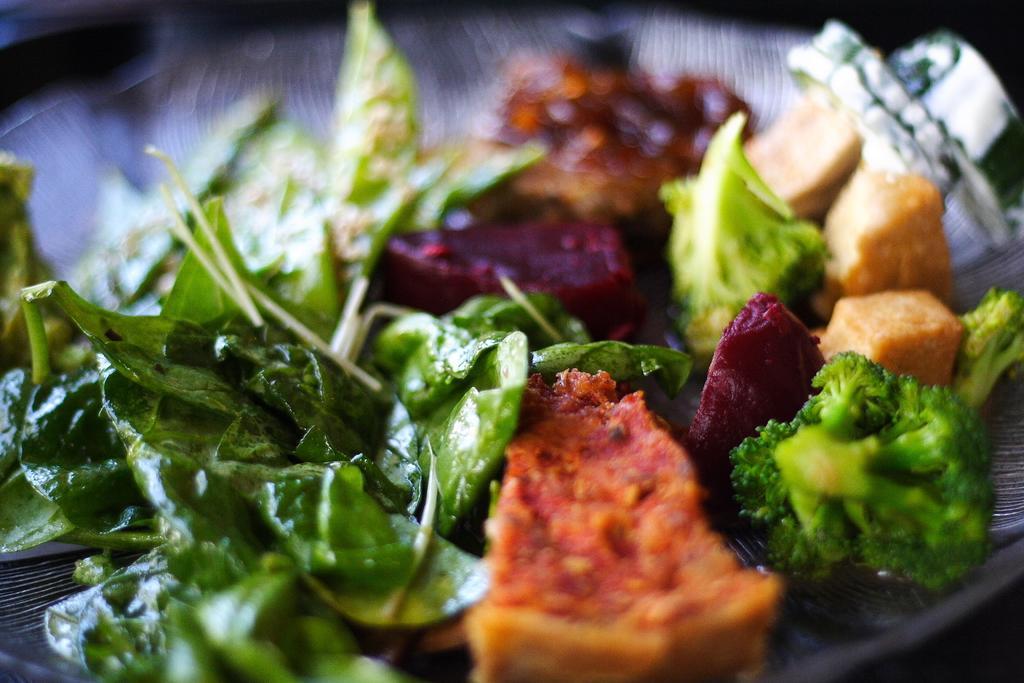Could you give a brief overview of what you see in this image? In this picture we can see vegetable leaves and food on a plate. In the background of the image it is blurry. 